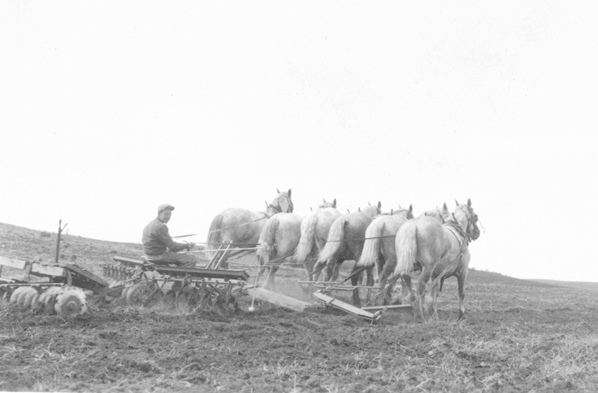<image>What color is the photo? I am not sure about the color of the photo. But it can be seen as black and white or gray and white. What color is the photo? The photo in the image is black and white. 